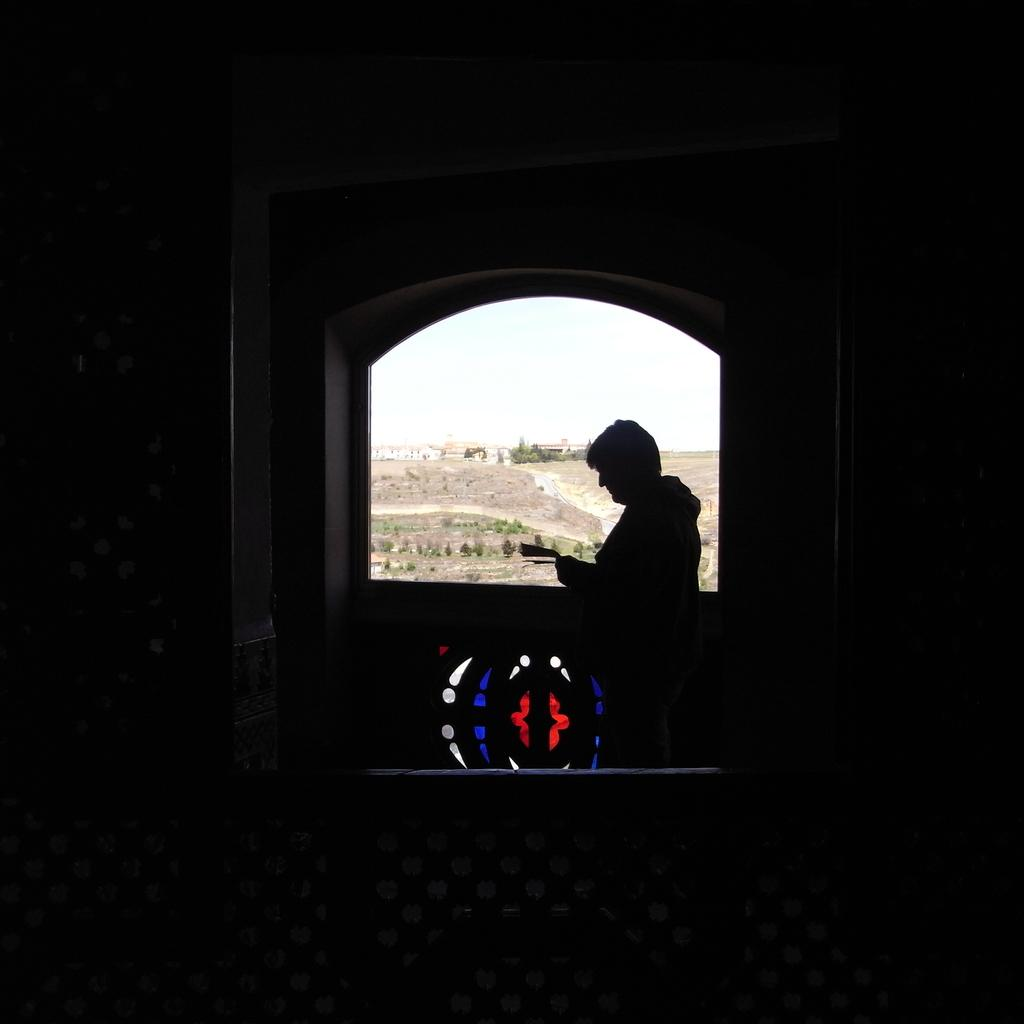What is the person in the image doing near the window? The person is standing near the window in the image. What can be seen outside the window? Trees, land, and a building are visible outside the window. What is the lighting condition in the foreground of the image? The foreground of the image is dark. What type of yam is being used as a cracker in the image? There is no yam or cracker present in the image. 